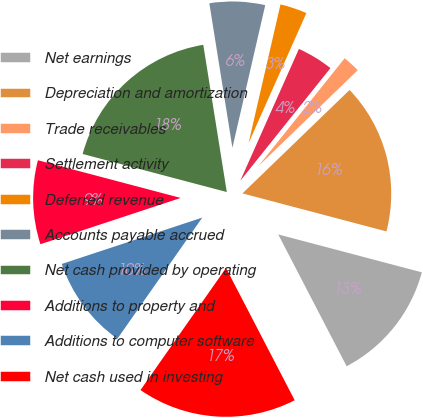Convert chart. <chart><loc_0><loc_0><loc_500><loc_500><pie_chart><fcel>Net earnings<fcel>Depreciation and amortization<fcel>Trade receivables<fcel>Settlement activity<fcel>Deferred revenue<fcel>Accounts payable accrued<fcel>Net cash provided by operating<fcel>Additions to property and<fcel>Additions to computer software<fcel>Net cash used in investing<nl><fcel>13.27%<fcel>16.33%<fcel>2.04%<fcel>4.08%<fcel>3.06%<fcel>6.12%<fcel>18.37%<fcel>9.18%<fcel>10.2%<fcel>17.35%<nl></chart> 